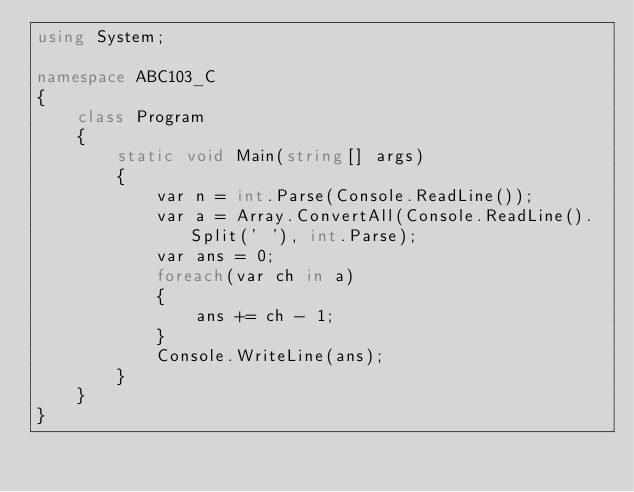<code> <loc_0><loc_0><loc_500><loc_500><_C#_>using System;

namespace ABC103_C
{
    class Program
    {
        static void Main(string[] args)
        {
            var n = int.Parse(Console.ReadLine());
            var a = Array.ConvertAll(Console.ReadLine().Split(' '), int.Parse);
            var ans = 0;
            foreach(var ch in a)
            {
                ans += ch - 1;
            }
            Console.WriteLine(ans);
        }
    }
}
</code> 